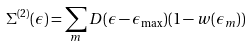<formula> <loc_0><loc_0><loc_500><loc_500>\Sigma ^ { ( 2 ) } ( \epsilon ) = \sum _ { m } D ( \epsilon - \epsilon _ { \max } ) ( 1 - w ( \epsilon _ { m } ) )</formula> 